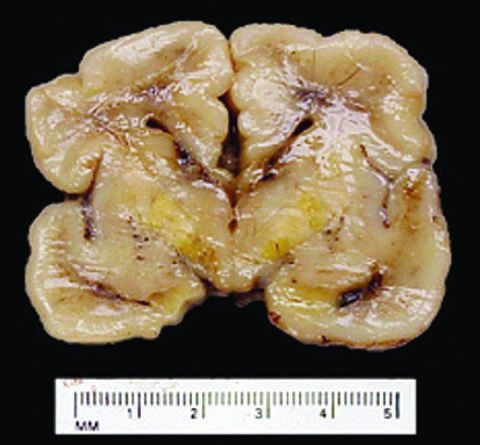what develop long-term neurologic sequelae?
Answer the question using a single word or phrase. Infants who survive 